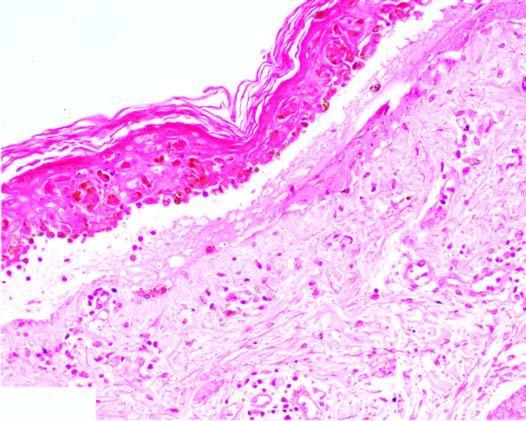s luminal surface of longitudinal cut section oedema and necrosis of kertinocytes at the junction and mild lymphocytic infiltrate?
Answer the question using a single word or phrase. No 